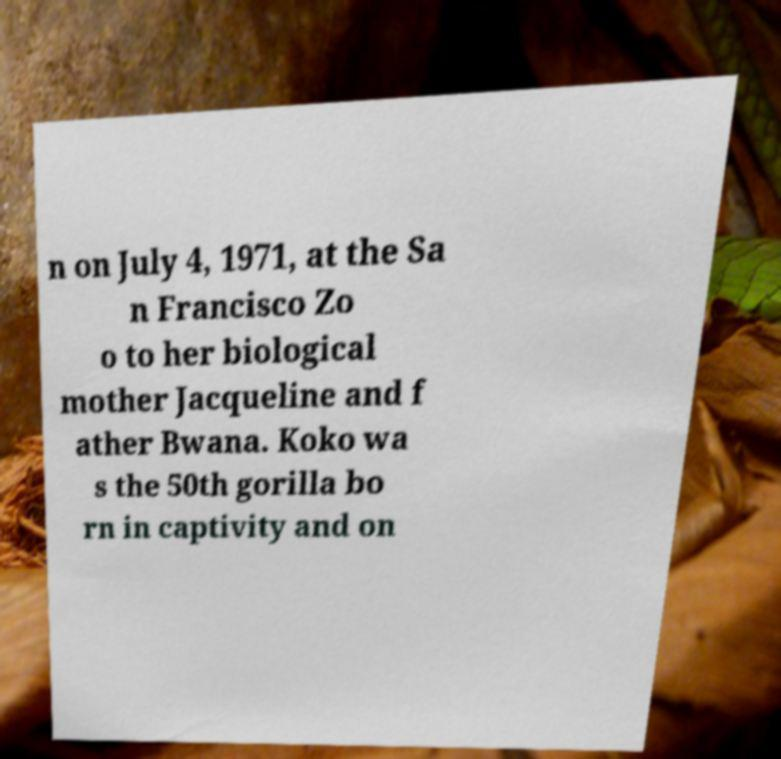Could you extract and type out the text from this image? n on July 4, 1971, at the Sa n Francisco Zo o to her biological mother Jacqueline and f ather Bwana. Koko wa s the 50th gorilla bo rn in captivity and on 